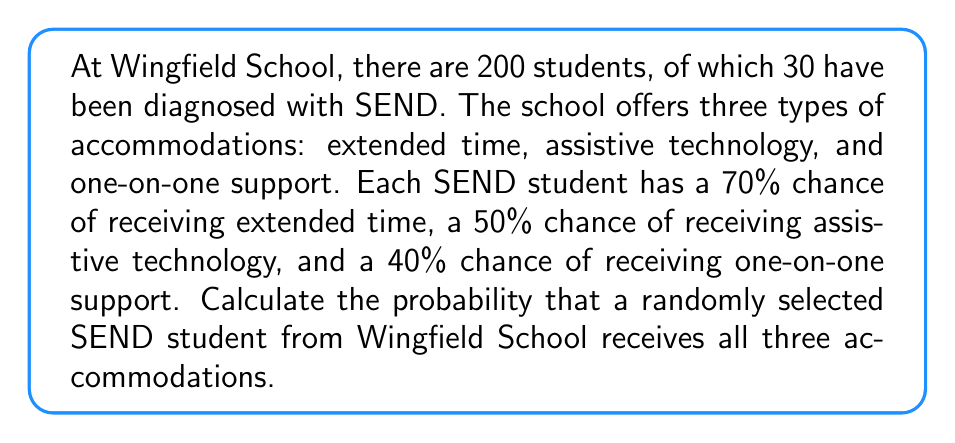Could you help me with this problem? Let's approach this step-by-step:

1) First, we need to understand that we're looking for the probability of a student receiving all three accommodations. This means we need to calculate the probability of three independent events occurring together.

2) The probabilities for each accommodation are:
   - Extended time: 70% or 0.70
   - Assistive technology: 50% or 0.50
   - One-on-one support: 40% or 0.40

3) To find the probability of all these independent events occurring together, we multiply their individual probabilities:

   $$P(\text{All 3 accommodations}) = P(\text{Extended time}) \times P(\text{Assistive tech}) \times P(\text{One-on-one})$$

4) Substituting the values:

   $$P(\text{All 3 accommodations}) = 0.70 \times 0.50 \times 0.40$$

5) Calculating:

   $$P(\text{All 3 accommodations}) = 0.14$$

6) Converting to a percentage:

   $$0.14 \times 100\% = 14\%$$

Therefore, the probability that a randomly selected SEND student from Wingfield School receives all three accommodations is 14% or 0.14.
Answer: 0.14 or 14% 